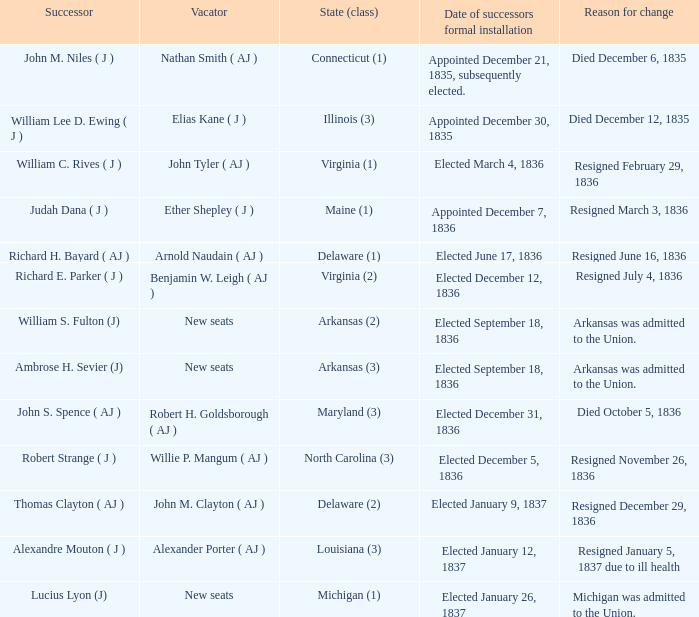Name the successor for elected january 26, 1837 1.0. 